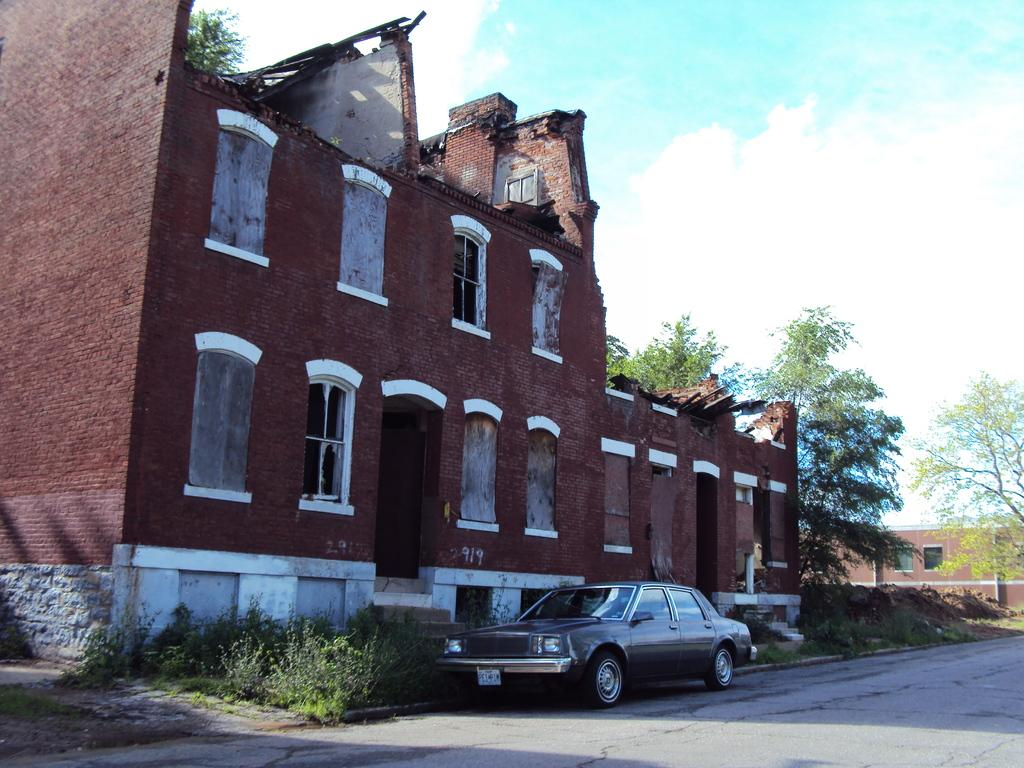What type of structures can be seen in the image? There are buildings in the image. What mode of transportation is visible on the road? There is a car on the road in the image. What type of vegetation is present in the image? There are plants and trees in the image. What is visible at the top of the image? The sky is visible at the top of the image. What can be observed in the sky? Clouds are present in the sky. What type of bomb is being dropped from the sky in the image? There is no bomb present in the image; it features buildings, a car, plants, trees, and a sky with clouds. What knowledge is being shared among the people in the image? There is no indication of people sharing knowledge in the image; it primarily focuses on the physical environment. 